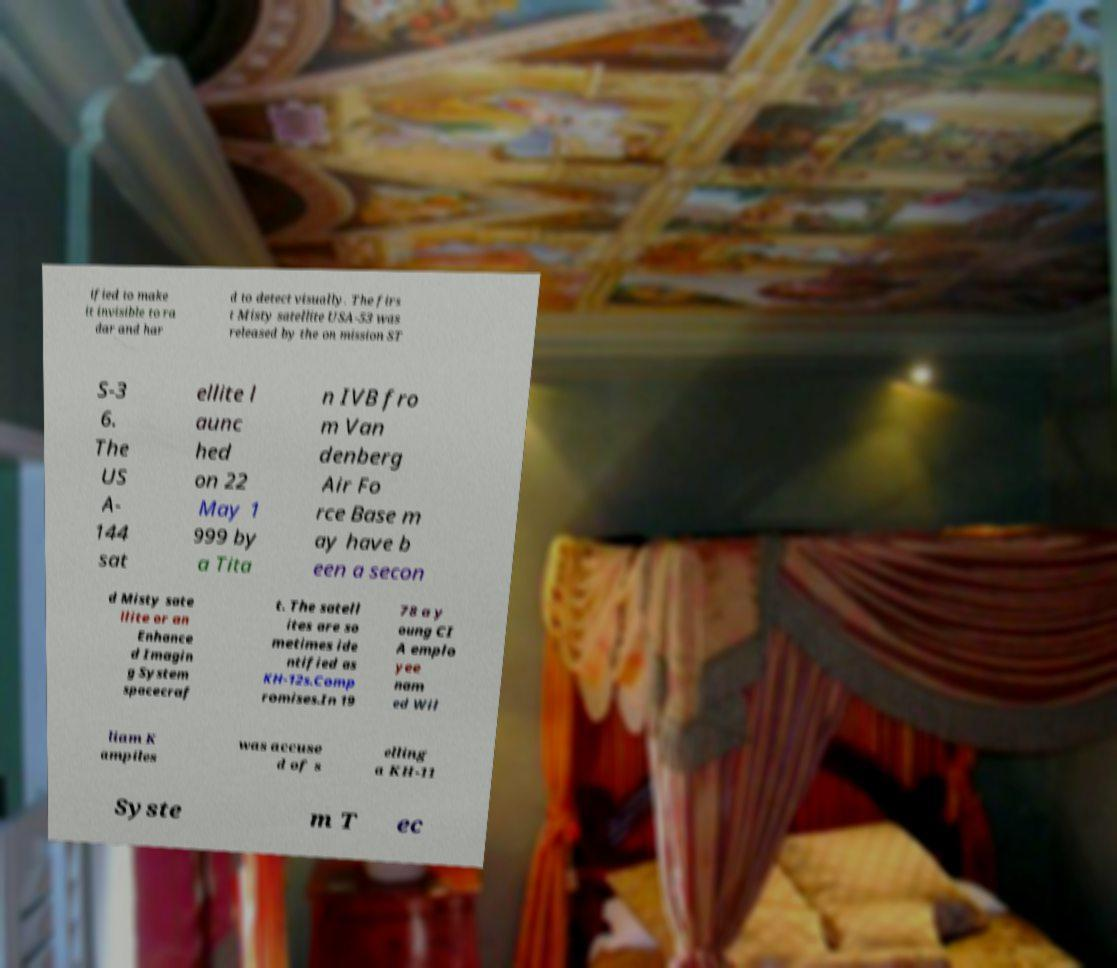I need the written content from this picture converted into text. Can you do that? ified to make it invisible to ra dar and har d to detect visually. The firs t Misty satellite USA-53 was released by the on mission ST S-3 6. The US A- 144 sat ellite l aunc hed on 22 May 1 999 by a Tita n IVB fro m Van denberg Air Fo rce Base m ay have b een a secon d Misty sate llite or an Enhance d Imagin g System spacecraf t. The satell ites are so metimes ide ntified as KH-12s.Comp romises.In 19 78 a y oung CI A emplo yee nam ed Wil liam K ampiles was accuse d of s elling a KH-11 Syste m T ec 